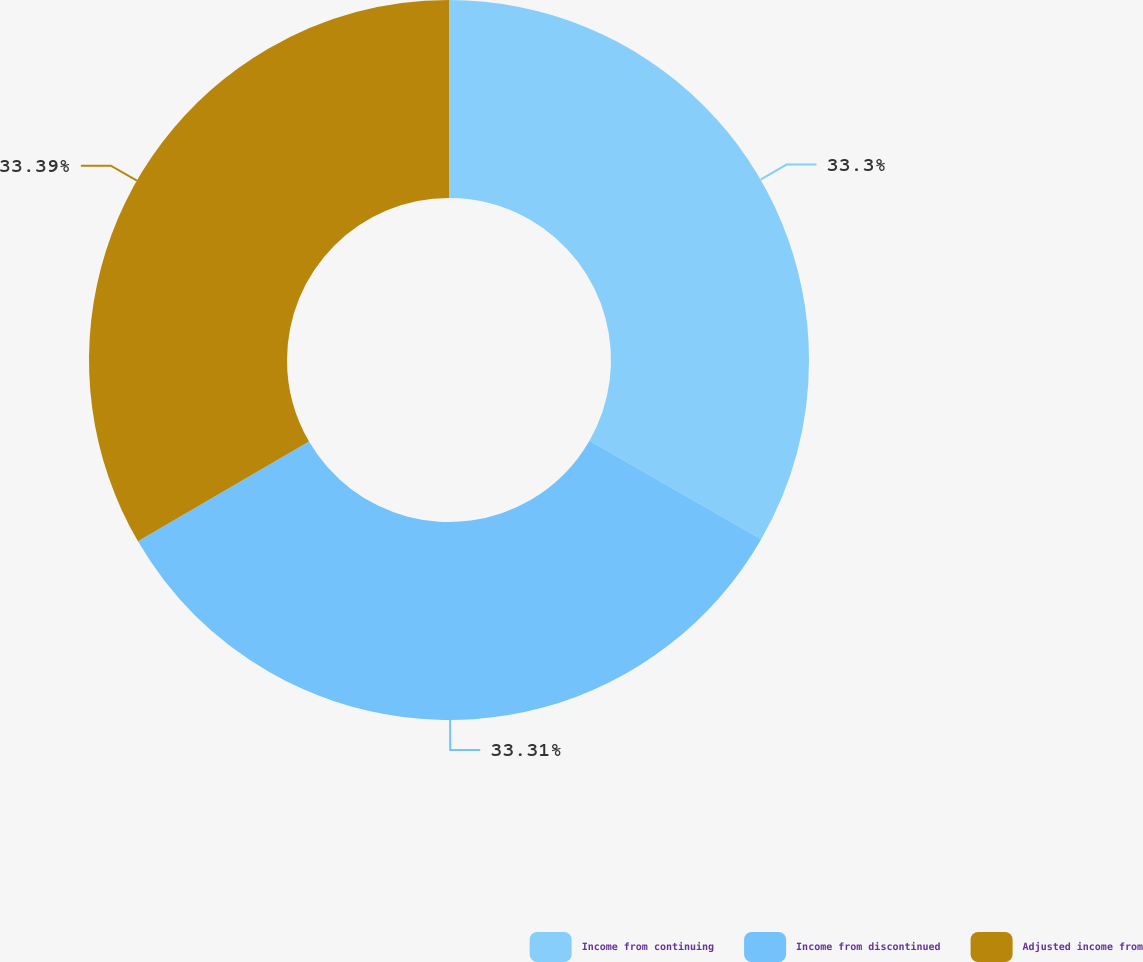<chart> <loc_0><loc_0><loc_500><loc_500><pie_chart><fcel>Income from continuing<fcel>Income from discontinued<fcel>Adjusted income from<nl><fcel>33.3%<fcel>33.31%<fcel>33.4%<nl></chart> 